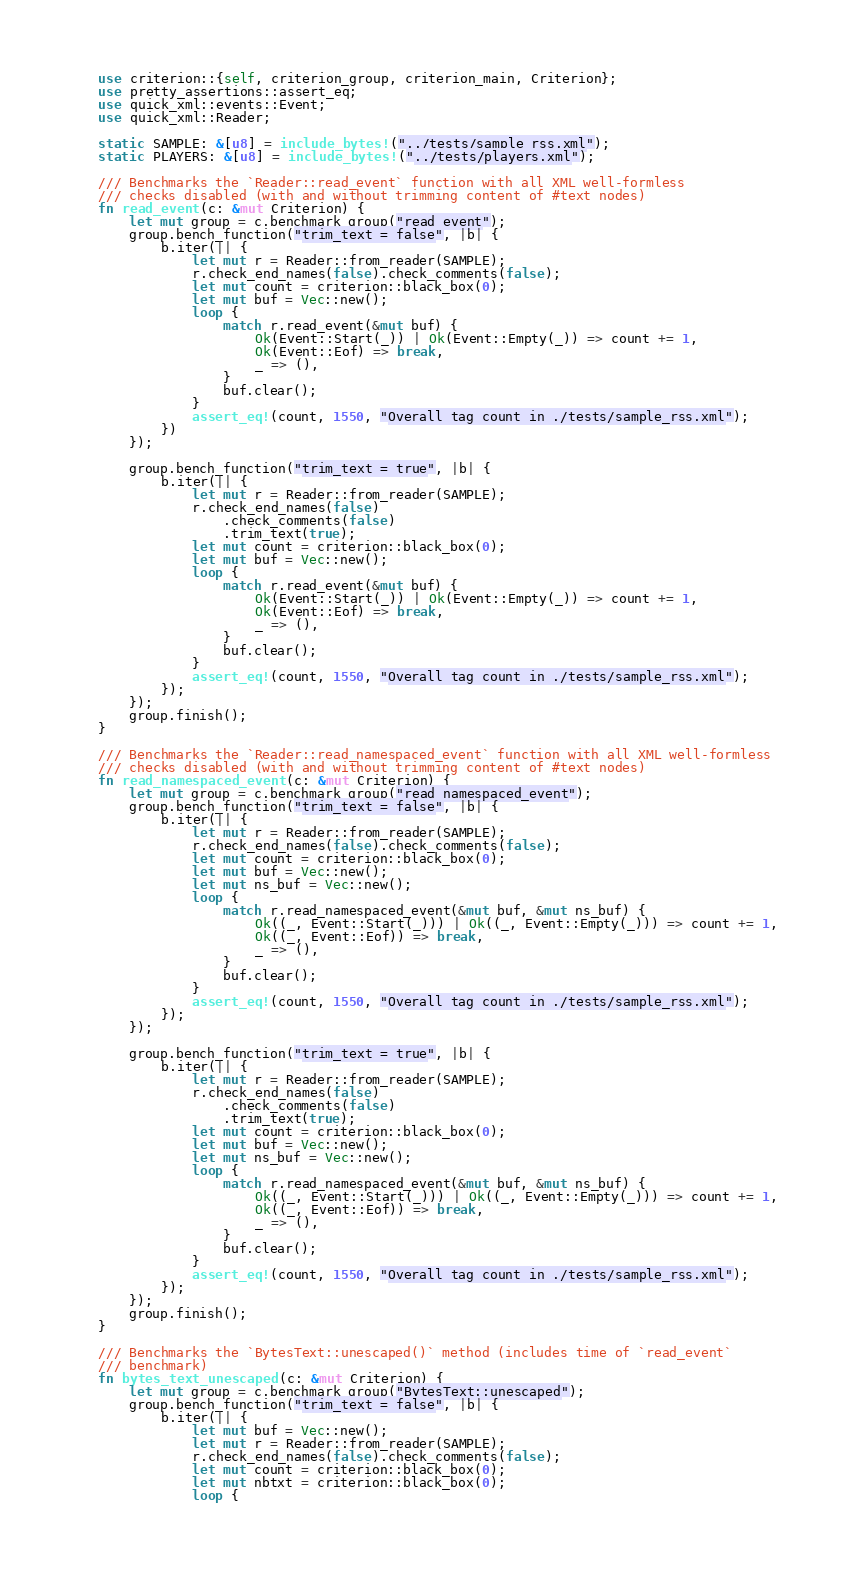Convert code to text. <code><loc_0><loc_0><loc_500><loc_500><_Rust_>use criterion::{self, criterion_group, criterion_main, Criterion};
use pretty_assertions::assert_eq;
use quick_xml::events::Event;
use quick_xml::Reader;

static SAMPLE: &[u8] = include_bytes!("../tests/sample_rss.xml");
static PLAYERS: &[u8] = include_bytes!("../tests/players.xml");

/// Benchmarks the `Reader::read_event` function with all XML well-formless
/// checks disabled (with and without trimming content of #text nodes)
fn read_event(c: &mut Criterion) {
    let mut group = c.benchmark_group("read_event");
    group.bench_function("trim_text = false", |b| {
        b.iter(|| {
            let mut r = Reader::from_reader(SAMPLE);
            r.check_end_names(false).check_comments(false);
            let mut count = criterion::black_box(0);
            let mut buf = Vec::new();
            loop {
                match r.read_event(&mut buf) {
                    Ok(Event::Start(_)) | Ok(Event::Empty(_)) => count += 1,
                    Ok(Event::Eof) => break,
                    _ => (),
                }
                buf.clear();
            }
            assert_eq!(count, 1550, "Overall tag count in ./tests/sample_rss.xml");
        })
    });

    group.bench_function("trim_text = true", |b| {
        b.iter(|| {
            let mut r = Reader::from_reader(SAMPLE);
            r.check_end_names(false)
                .check_comments(false)
                .trim_text(true);
            let mut count = criterion::black_box(0);
            let mut buf = Vec::new();
            loop {
                match r.read_event(&mut buf) {
                    Ok(Event::Start(_)) | Ok(Event::Empty(_)) => count += 1,
                    Ok(Event::Eof) => break,
                    _ => (),
                }
                buf.clear();
            }
            assert_eq!(count, 1550, "Overall tag count in ./tests/sample_rss.xml");
        });
    });
    group.finish();
}

/// Benchmarks the `Reader::read_namespaced_event` function with all XML well-formless
/// checks disabled (with and without trimming content of #text nodes)
fn read_namespaced_event(c: &mut Criterion) {
    let mut group = c.benchmark_group("read_namespaced_event");
    group.bench_function("trim_text = false", |b| {
        b.iter(|| {
            let mut r = Reader::from_reader(SAMPLE);
            r.check_end_names(false).check_comments(false);
            let mut count = criterion::black_box(0);
            let mut buf = Vec::new();
            let mut ns_buf = Vec::new();
            loop {
                match r.read_namespaced_event(&mut buf, &mut ns_buf) {
                    Ok((_, Event::Start(_))) | Ok((_, Event::Empty(_))) => count += 1,
                    Ok((_, Event::Eof)) => break,
                    _ => (),
                }
                buf.clear();
            }
            assert_eq!(count, 1550, "Overall tag count in ./tests/sample_rss.xml");
        });
    });

    group.bench_function("trim_text = true", |b| {
        b.iter(|| {
            let mut r = Reader::from_reader(SAMPLE);
            r.check_end_names(false)
                .check_comments(false)
                .trim_text(true);
            let mut count = criterion::black_box(0);
            let mut buf = Vec::new();
            let mut ns_buf = Vec::new();
            loop {
                match r.read_namespaced_event(&mut buf, &mut ns_buf) {
                    Ok((_, Event::Start(_))) | Ok((_, Event::Empty(_))) => count += 1,
                    Ok((_, Event::Eof)) => break,
                    _ => (),
                }
                buf.clear();
            }
            assert_eq!(count, 1550, "Overall tag count in ./tests/sample_rss.xml");
        });
    });
    group.finish();
}

/// Benchmarks the `BytesText::unescaped()` method (includes time of `read_event`
/// benchmark)
fn bytes_text_unescaped(c: &mut Criterion) {
    let mut group = c.benchmark_group("BytesText::unescaped");
    group.bench_function("trim_text = false", |b| {
        b.iter(|| {
            let mut buf = Vec::new();
            let mut r = Reader::from_reader(SAMPLE);
            r.check_end_names(false).check_comments(false);
            let mut count = criterion::black_box(0);
            let mut nbtxt = criterion::black_box(0);
            loop {</code> 